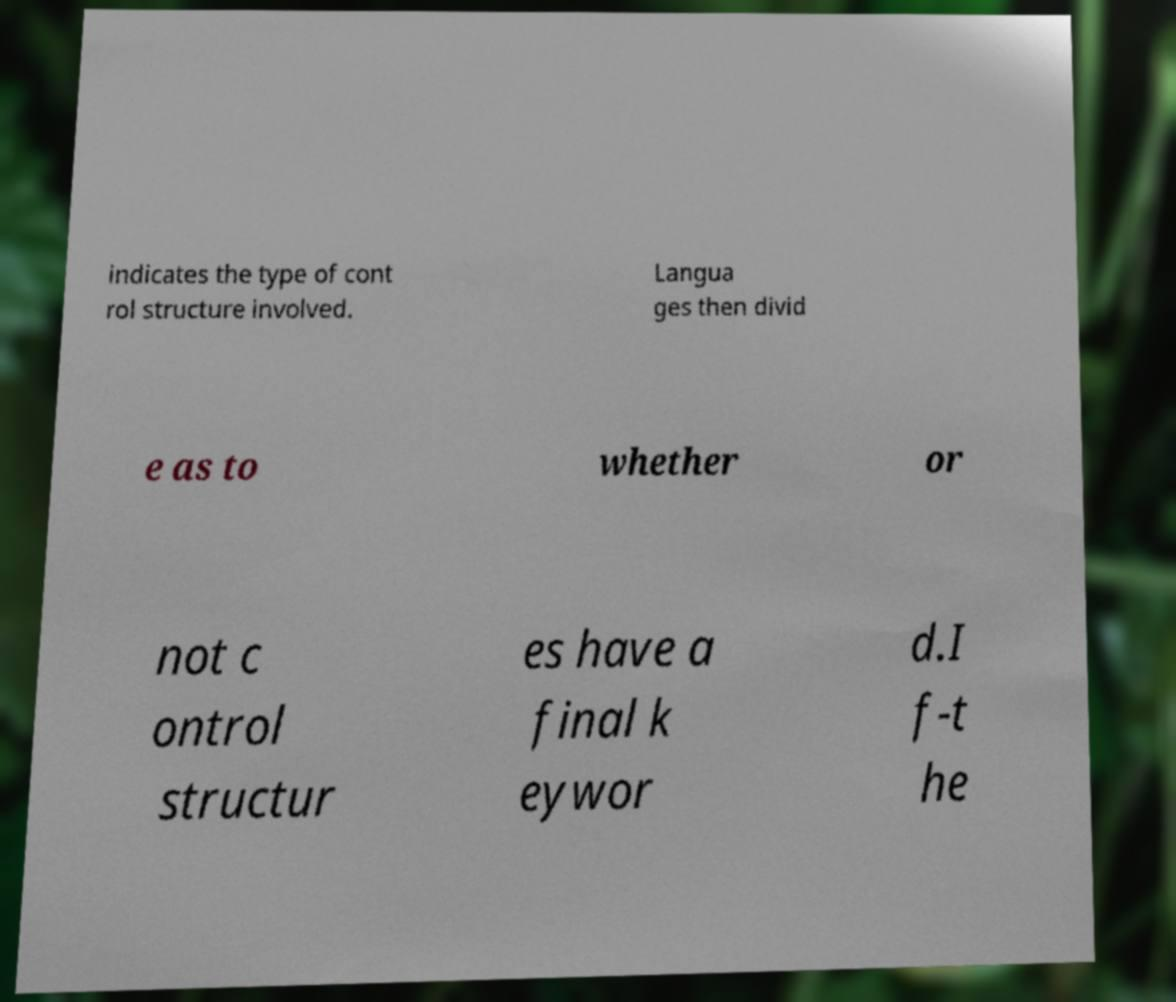What messages or text are displayed in this image? I need them in a readable, typed format. indicates the type of cont rol structure involved. Langua ges then divid e as to whether or not c ontrol structur es have a final k eywor d.I f-t he 